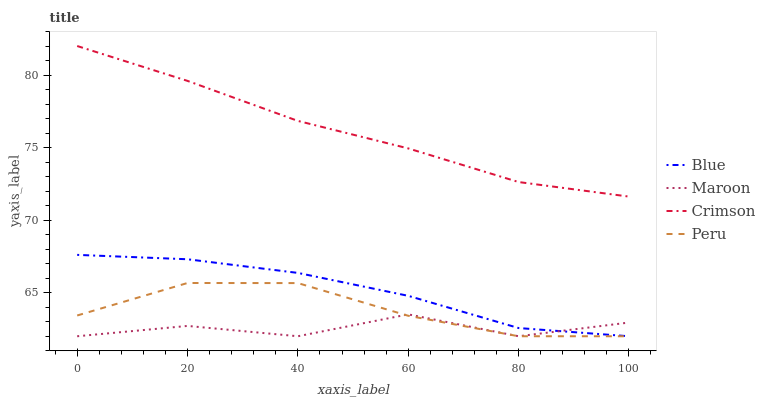Does Maroon have the minimum area under the curve?
Answer yes or no. Yes. Does Crimson have the maximum area under the curve?
Answer yes or no. Yes. Does Peru have the minimum area under the curve?
Answer yes or no. No. Does Peru have the maximum area under the curve?
Answer yes or no. No. Is Crimson the smoothest?
Answer yes or no. Yes. Is Maroon the roughest?
Answer yes or no. Yes. Is Peru the smoothest?
Answer yes or no. No. Is Peru the roughest?
Answer yes or no. No. Does Crimson have the lowest value?
Answer yes or no. No. Does Peru have the highest value?
Answer yes or no. No. Is Blue less than Crimson?
Answer yes or no. Yes. Is Crimson greater than Blue?
Answer yes or no. Yes. Does Blue intersect Crimson?
Answer yes or no. No. 